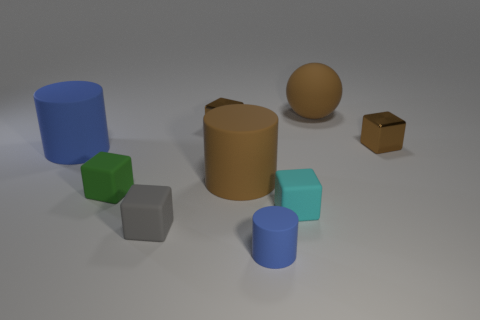There is a small cylinder that is the same material as the small cyan thing; what color is it?
Offer a very short reply. Blue. Is the number of small gray matte objects greater than the number of cyan metal cylinders?
Your response must be concise. Yes. Is there a purple matte thing?
Make the answer very short. No. There is a brown shiny thing that is to the left of the cyan thing in front of the large brown ball; what shape is it?
Provide a short and direct response. Cube. What number of things are either small green metal spheres or blue objects behind the small green block?
Give a very brief answer. 1. What color is the tiny cylinder on the left side of the big brown thing to the right of the tiny rubber cube that is right of the brown rubber cylinder?
Your answer should be very brief. Blue. What color is the sphere?
Offer a terse response. Brown. Does the big ball have the same color as the tiny cylinder?
Keep it short and to the point. No. What number of matte things are gray blocks or big blue objects?
Keep it short and to the point. 2. There is a metallic cube that is on the left side of the small brown thing on the right side of the big matte sphere; are there any blue things that are on the right side of it?
Offer a terse response. Yes. 